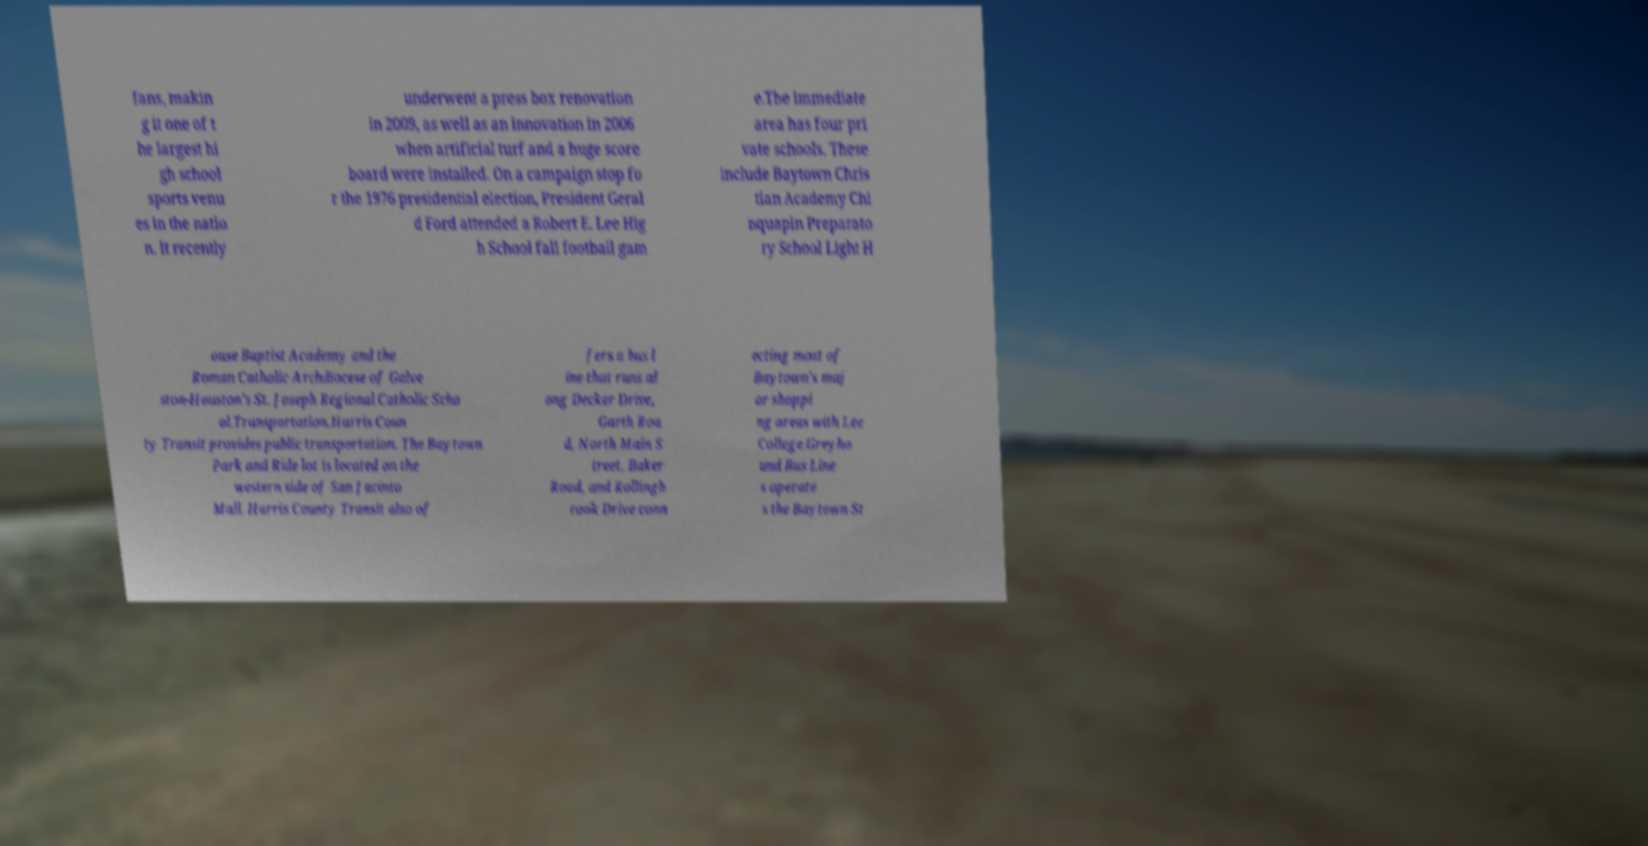What messages or text are displayed in this image? I need them in a readable, typed format. fans, makin g it one of t he largest hi gh school sports venu es in the natio n. It recently underwent a press box renovation in 2009, as well as an innovation in 2006 when artificial turf and a huge score board were installed. On a campaign stop fo r the 1976 presidential election, President Geral d Ford attended a Robert E. Lee Hig h School fall football gam e.The immediate area has four pri vate schools. These include Baytown Chris tian Academy Chi nquapin Preparato ry School Light H ouse Baptist Academy and the Roman Catholic Archdiocese of Galve ston-Houston’s St. Joseph Regional Catholic Scho ol.Transportation.Harris Coun ty Transit provides public transportation. The Baytown Park and Ride lot is located on the western side of San Jacinto Mall. Harris County Transit also of fers a bus l ine that runs al ong Decker Drive, Garth Roa d, North Main S treet, Baker Road, and Rollingb rook Drive conn ecting most of Baytown's maj or shoppi ng areas with Lee College.Greyho und Bus Line s operate s the Baytown St 